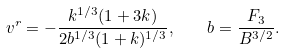<formula> <loc_0><loc_0><loc_500><loc_500>v ^ { r } = - \frac { k ^ { 1 / 3 } ( 1 + 3 k ) } { 2 b ^ { 1 / 3 } ( 1 + k ) ^ { 1 / 3 } } , \quad b = \frac { F _ { 3 } } { B ^ { 3 / 2 } } .</formula> 